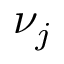Convert formula to latex. <formula><loc_0><loc_0><loc_500><loc_500>\nu _ { j }</formula> 